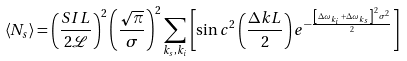Convert formula to latex. <formula><loc_0><loc_0><loc_500><loc_500>\left \langle N _ { s } \right \rangle = \left ( \frac { S I L } { 2 \mathcal { L } } \right ) ^ { 2 } \left ( \frac { \sqrt { \pi } } { \sigma } \right ) ^ { 2 } \sum _ { k _ { s } , k _ { i } } \left [ \sin c ^ { 2 } \left ( \frac { \Delta k L } { 2 } \right ) e ^ { - \frac { \left [ \Delta \omega _ { k _ { i } } + \Delta \omega _ { k _ { s } } \right ] ^ { 2 } \sigma ^ { 2 } } { 2 } } \right ]</formula> 